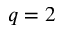Convert formula to latex. <formula><loc_0><loc_0><loc_500><loc_500>q = 2</formula> 